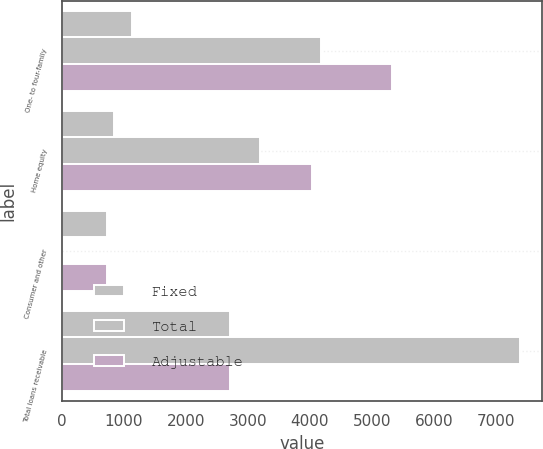<chart> <loc_0><loc_0><loc_500><loc_500><stacked_bar_chart><ecel><fcel>One- to four-family<fcel>Home equity<fcel>Consumer and other<fcel>Total loans receivable<nl><fcel>Fixed<fcel>1142.4<fcel>840.2<fcel>726.1<fcel>2708.7<nl><fcel>Total<fcel>4175.3<fcel>3194.8<fcel>7.2<fcel>7377.3<nl><fcel>Adjustable<fcel>5317.7<fcel>4035<fcel>733.3<fcel>2708.7<nl></chart> 